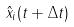Convert formula to latex. <formula><loc_0><loc_0><loc_500><loc_500>\hat { x } _ { i } ( t + \Delta t )</formula> 